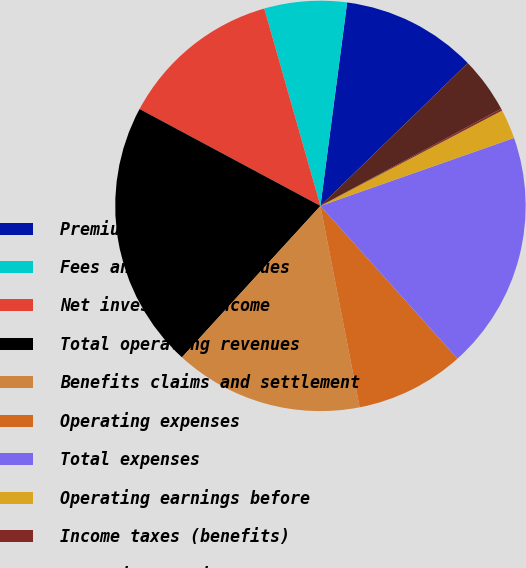Convert chart to OTSL. <chart><loc_0><loc_0><loc_500><loc_500><pie_chart><fcel>Premiums and other<fcel>Fees and other revenues<fcel>Net investment income<fcel>Total operating revenues<fcel>Benefits claims and settlement<fcel>Operating expenses<fcel>Total expenses<fcel>Operating earnings before<fcel>Income taxes (benefits)<fcel>Operating earnings<nl><fcel>10.67%<fcel>6.49%<fcel>12.76%<fcel>21.04%<fcel>14.85%<fcel>8.58%<fcel>18.73%<fcel>2.32%<fcel>0.16%<fcel>4.4%<nl></chart> 